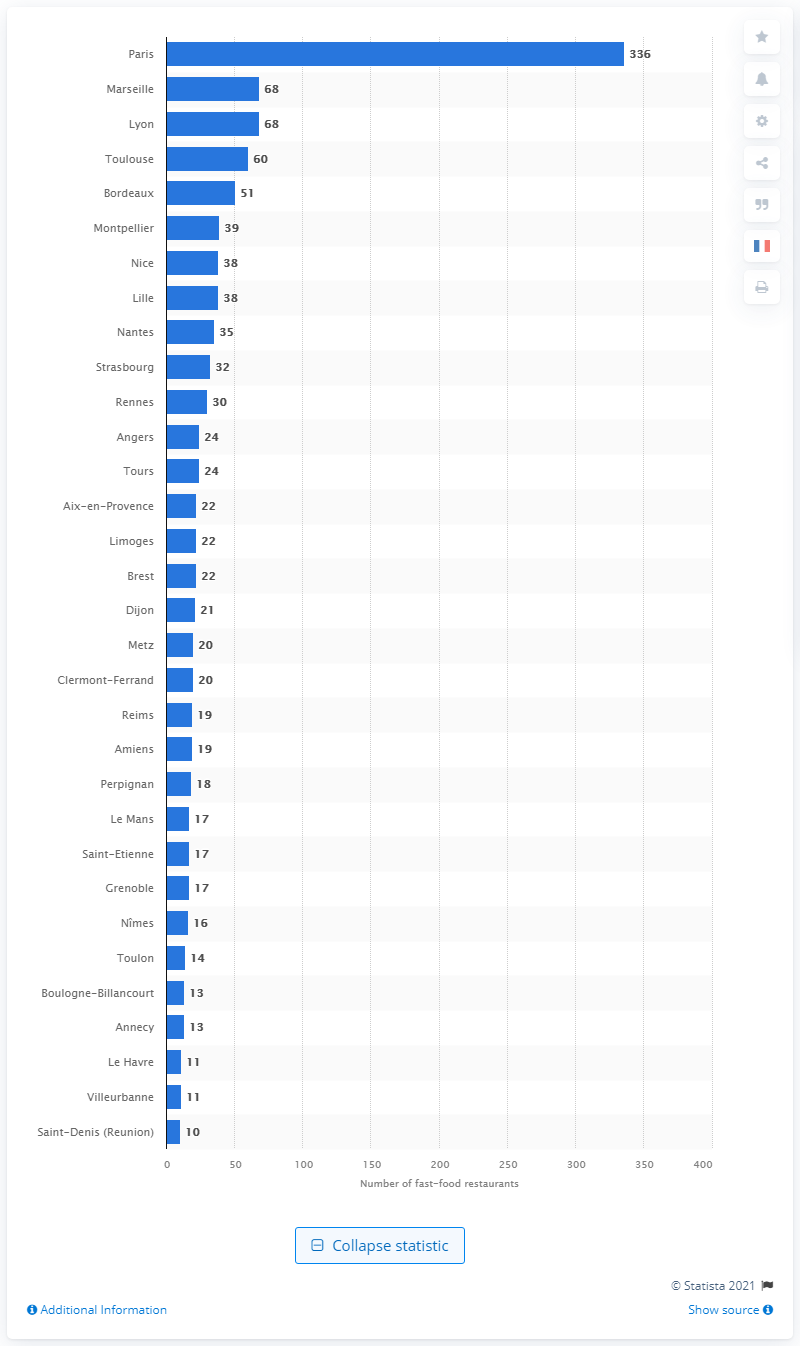Specify some key components in this picture. In 2021, the number of fast food restaurants in Paris was 336. According to data collected in 2021, Paris had the highest density of fast food restaurants in France. 